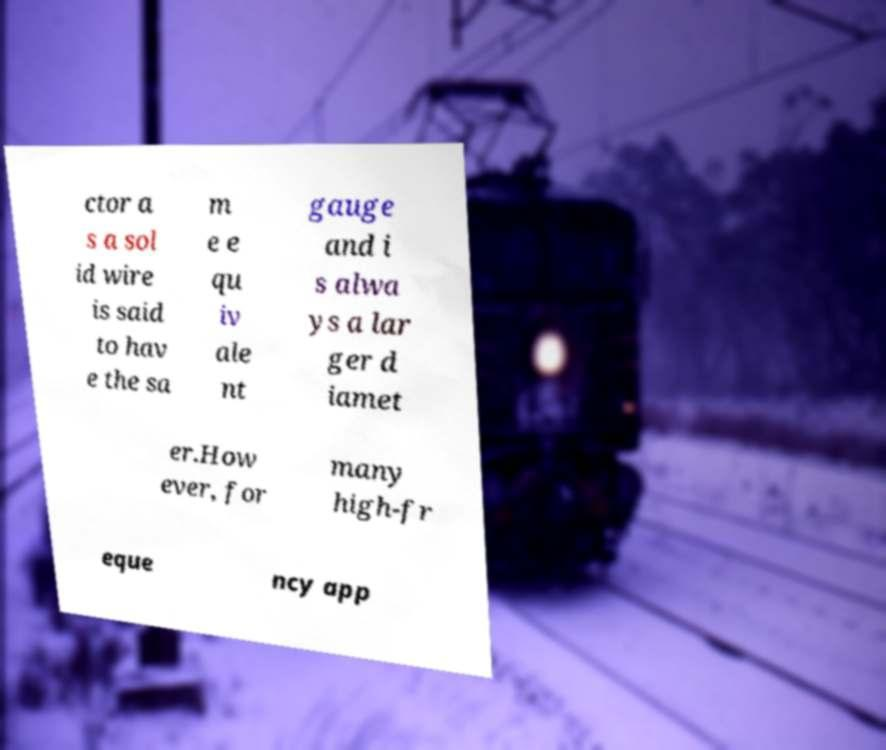Could you assist in decoding the text presented in this image and type it out clearly? ctor a s a sol id wire is said to hav e the sa m e e qu iv ale nt gauge and i s alwa ys a lar ger d iamet er.How ever, for many high-fr eque ncy app 